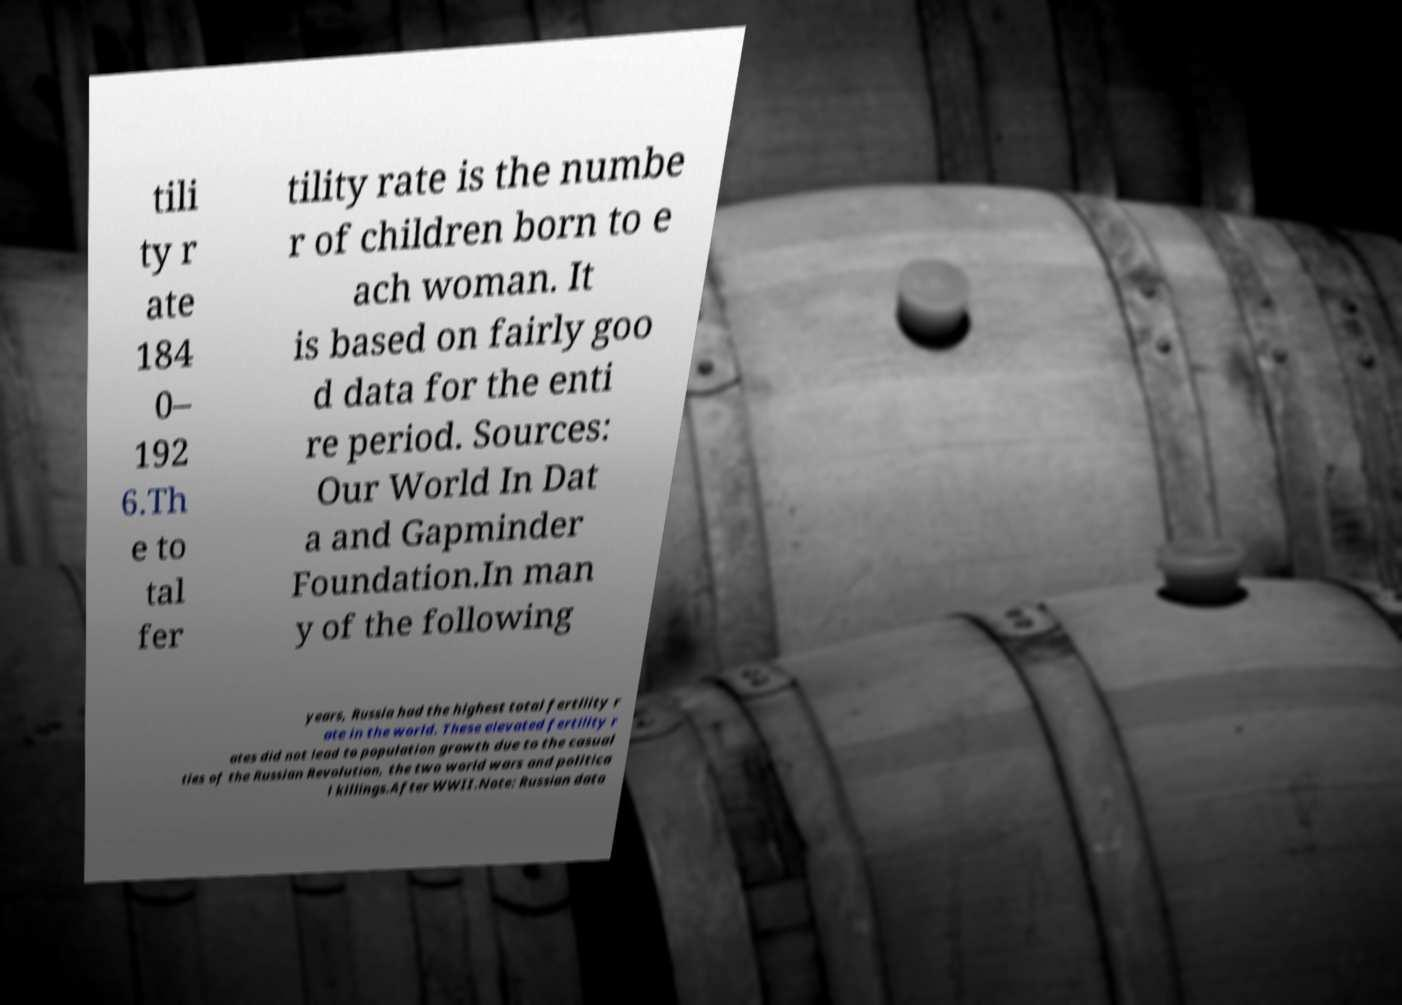Could you assist in decoding the text presented in this image and type it out clearly? tili ty r ate 184 0– 192 6.Th e to tal fer tility rate is the numbe r of children born to e ach woman. It is based on fairly goo d data for the enti re period. Sources: Our World In Dat a and Gapminder Foundation.In man y of the following years, Russia had the highest total fertility r ate in the world. These elevated fertility r ates did not lead to population growth due to the casual ties of the Russian Revolution, the two world wars and politica l killings.After WWII.Note: Russian data 